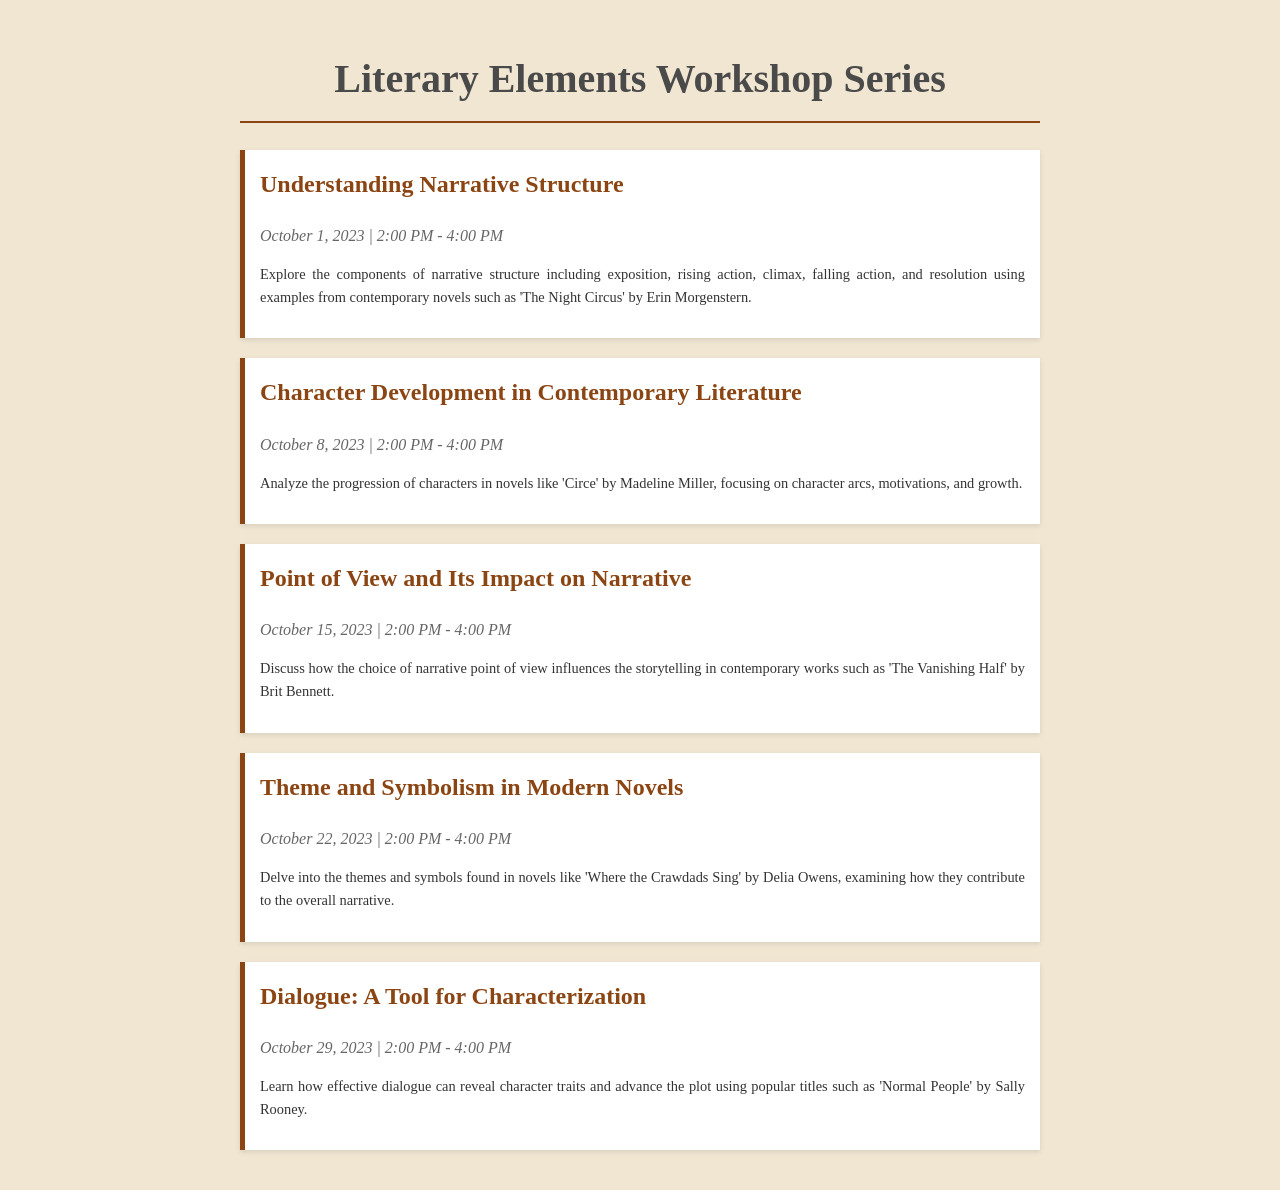What is the title of the first workshop? The title of the first workshop can be found at the top of its section in the document.
Answer: Understanding Narrative Structure What is the date of the second workshop? The date of the second workshop is indicated in the date-time section of the workshop.
Answer: October 8, 2023 What is the main focus of the workshop on October 15, 2023? The focus of the workshop can be found in the description section provided for that date.
Answer: Point of View and Its Impact on Narrative How long is each workshop scheduled to last? The duration of each workshop is mentioned in the date-time section of the workshops.
Answer: 2 hours Which novel is used as an example in the workshop about dialogue? The example novel for the dialogue workshop can be found in the description section of that workshop.
Answer: Normal People What is the name of the facilitator for the workshop series? The document does not provide information on the facilitator, as it focuses on workshop details.
Answer: (Not provided) What is the theme of the last workshop in the series? The theme can be determined by reading the title of the last workshop listed in the document.
Answer: Dialogue: A Tool for Characterization In which month do the workshops begin? The workshops start on the first date presented in the document, which is outlined in the schedule.
Answer: October 